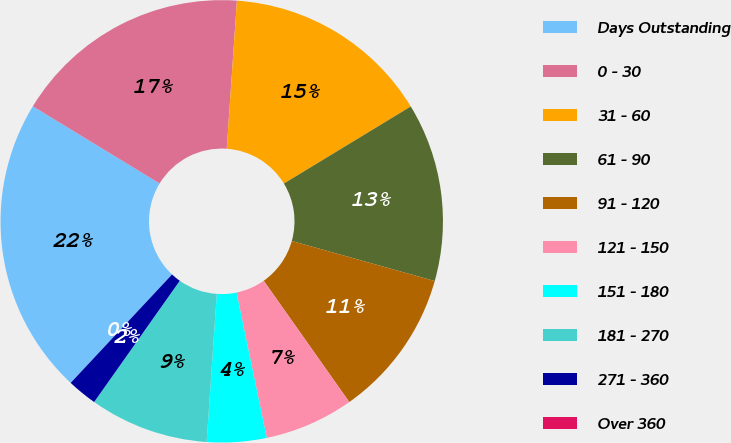Convert chart. <chart><loc_0><loc_0><loc_500><loc_500><pie_chart><fcel>Days Outstanding<fcel>0 - 30<fcel>31 - 60<fcel>61 - 90<fcel>91 - 120<fcel>121 - 150<fcel>151 - 180<fcel>181 - 270<fcel>271 - 360<fcel>Over 360<nl><fcel>21.74%<fcel>17.39%<fcel>15.22%<fcel>13.04%<fcel>10.87%<fcel>6.52%<fcel>4.35%<fcel>8.7%<fcel>2.18%<fcel>0.0%<nl></chart> 